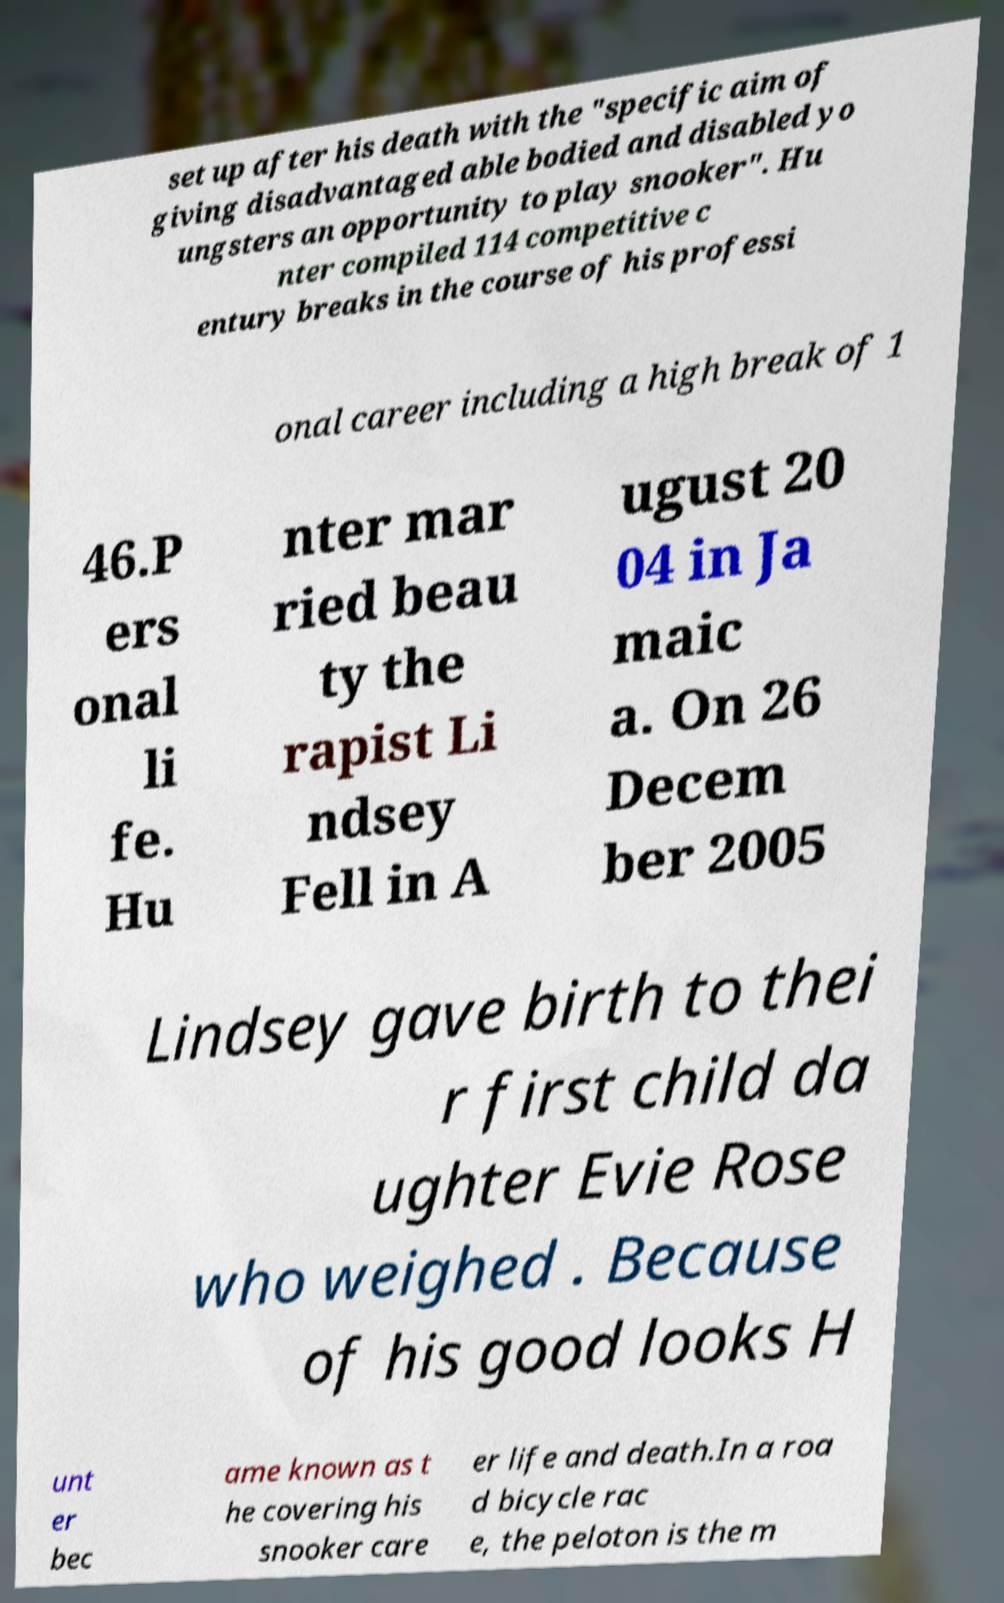Please identify and transcribe the text found in this image. set up after his death with the "specific aim of giving disadvantaged able bodied and disabled yo ungsters an opportunity to play snooker". Hu nter compiled 114 competitive c entury breaks in the course of his professi onal career including a high break of 1 46.P ers onal li fe. Hu nter mar ried beau ty the rapist Li ndsey Fell in A ugust 20 04 in Ja maic a. On 26 Decem ber 2005 Lindsey gave birth to thei r first child da ughter Evie Rose who weighed . Because of his good looks H unt er bec ame known as t he covering his snooker care er life and death.In a roa d bicycle rac e, the peloton is the m 